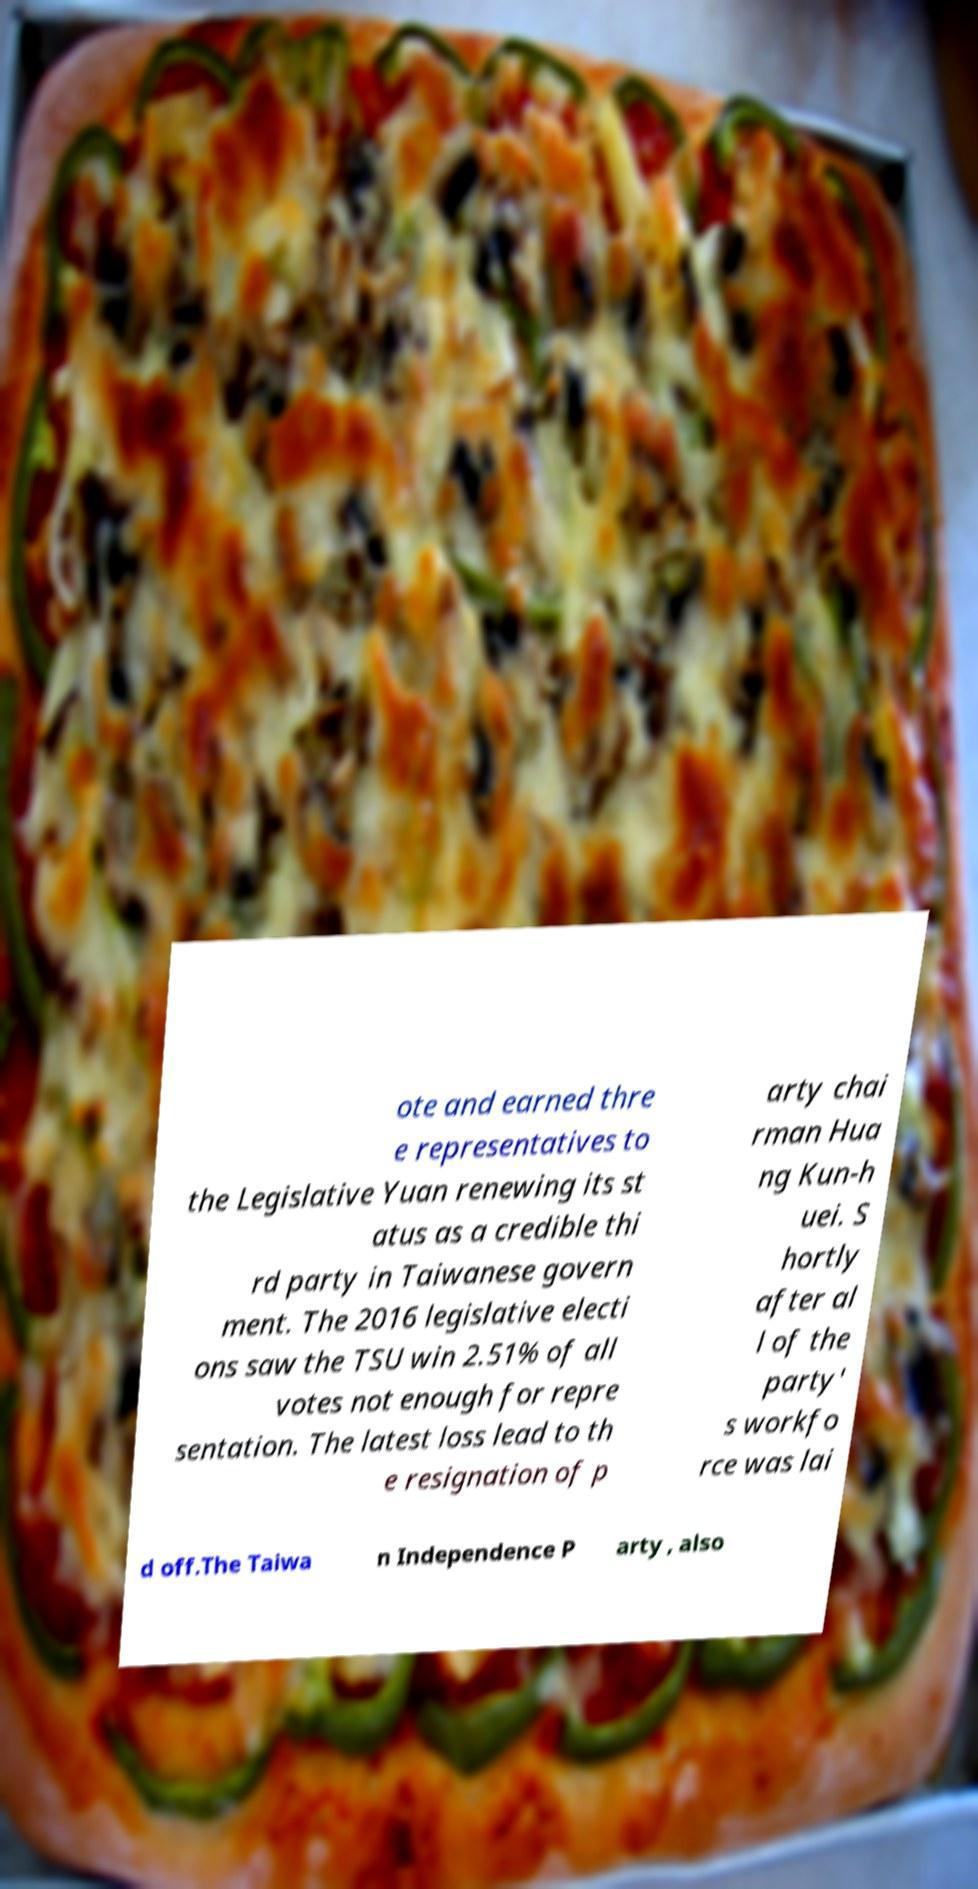Please read and relay the text visible in this image. What does it say? ote and earned thre e representatives to the Legislative Yuan renewing its st atus as a credible thi rd party in Taiwanese govern ment. The 2016 legislative electi ons saw the TSU win 2.51% of all votes not enough for repre sentation. The latest loss lead to th e resignation of p arty chai rman Hua ng Kun-h uei. S hortly after al l of the party' s workfo rce was lai d off.The Taiwa n Independence P arty , also 